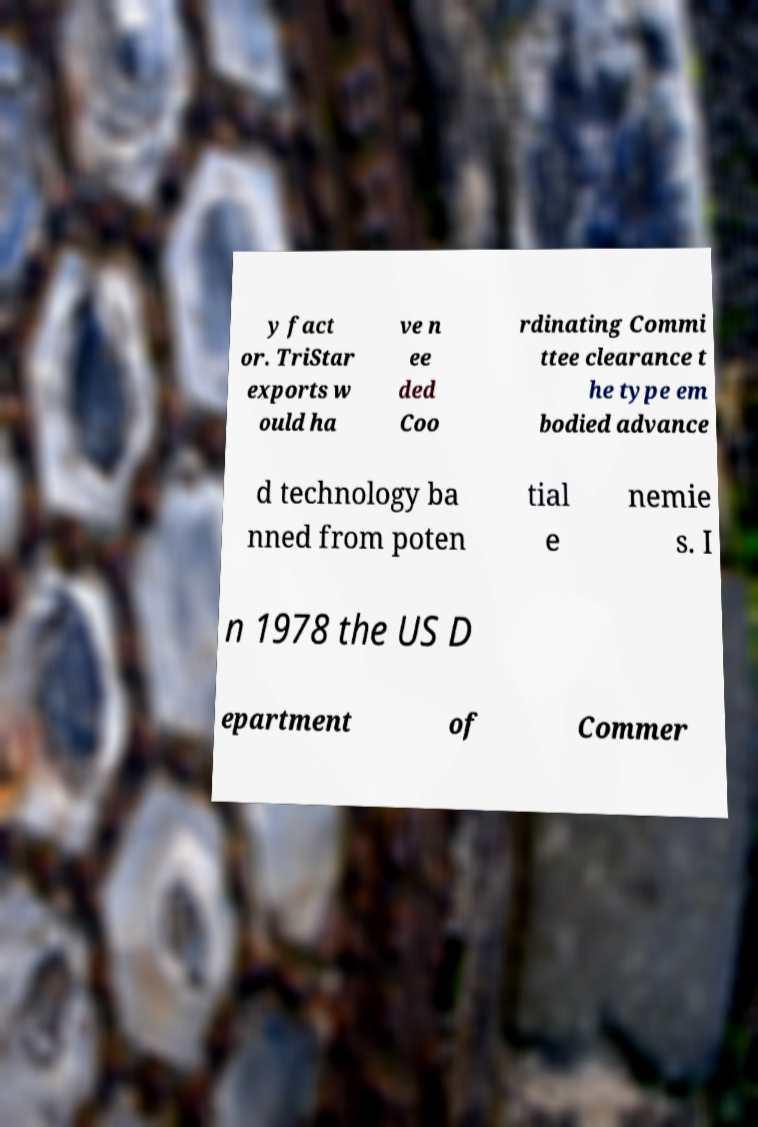For documentation purposes, I need the text within this image transcribed. Could you provide that? y fact or. TriStar exports w ould ha ve n ee ded Coo rdinating Commi ttee clearance t he type em bodied advance d technology ba nned from poten tial e nemie s. I n 1978 the US D epartment of Commer 